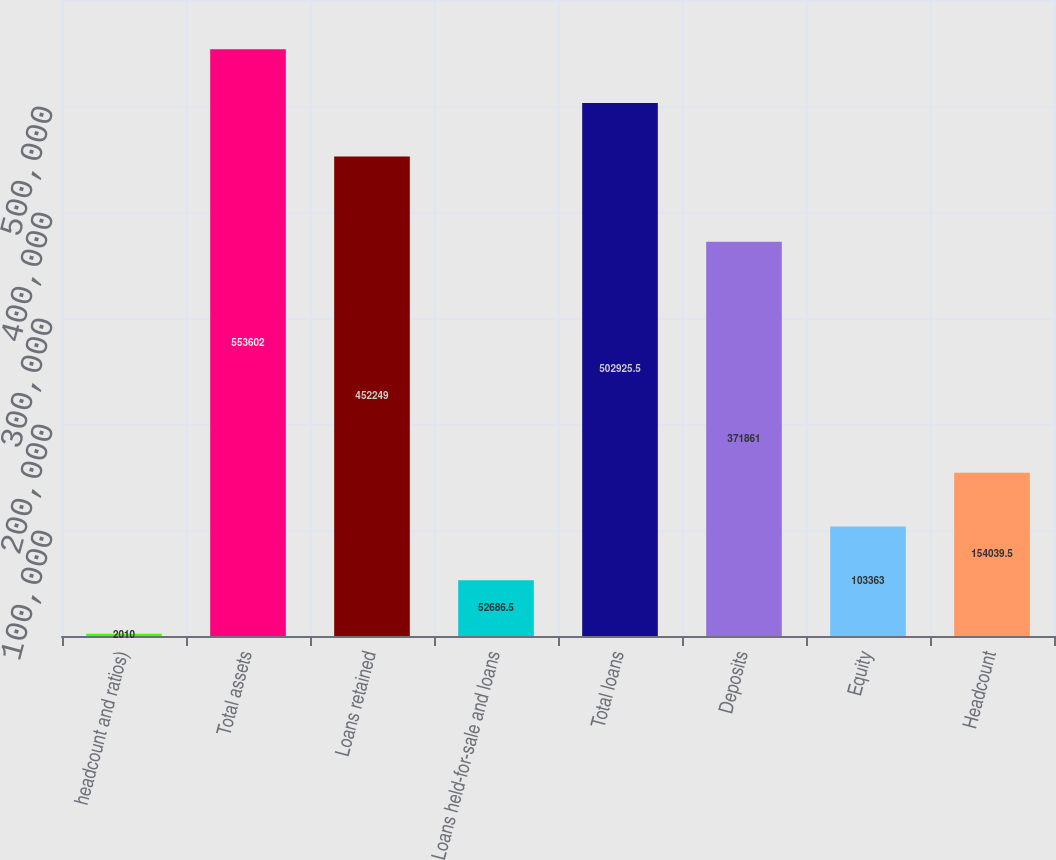Convert chart. <chart><loc_0><loc_0><loc_500><loc_500><bar_chart><fcel>headcount and ratios)<fcel>Total assets<fcel>Loans retained<fcel>Loans held-for-sale and loans<fcel>Total loans<fcel>Deposits<fcel>Equity<fcel>Headcount<nl><fcel>2010<fcel>553602<fcel>452249<fcel>52686.5<fcel>502926<fcel>371861<fcel>103363<fcel>154040<nl></chart> 